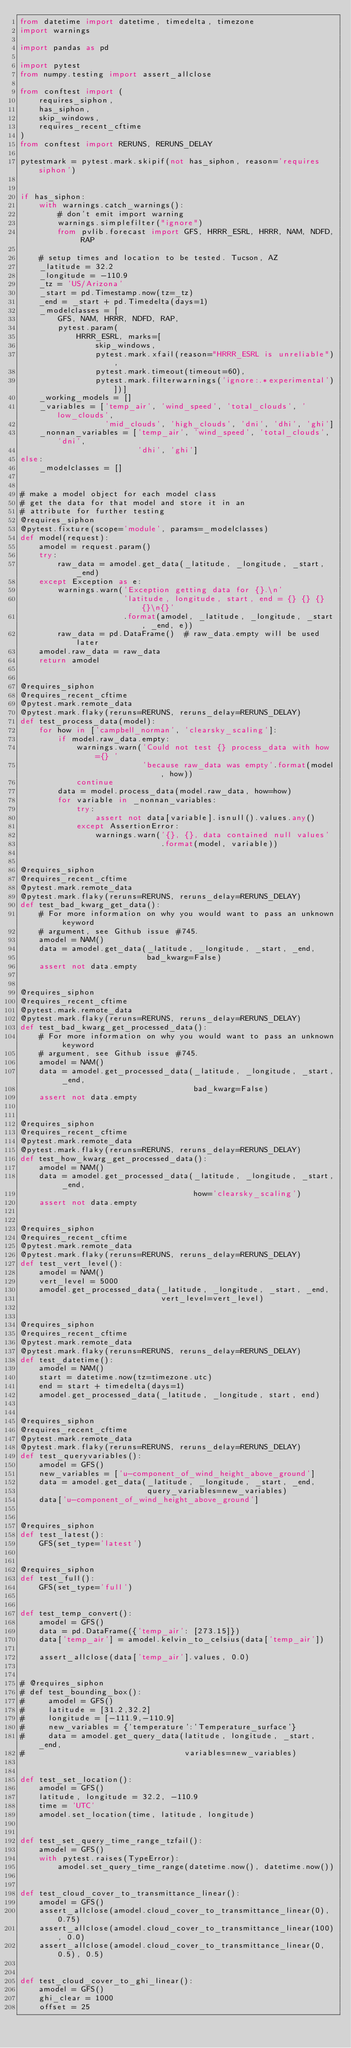Convert code to text. <code><loc_0><loc_0><loc_500><loc_500><_Python_>from datetime import datetime, timedelta, timezone
import warnings

import pandas as pd

import pytest
from numpy.testing import assert_allclose

from conftest import (
    requires_siphon,
    has_siphon,
    skip_windows,
    requires_recent_cftime
)
from conftest import RERUNS, RERUNS_DELAY

pytestmark = pytest.mark.skipif(not has_siphon, reason='requires siphon')


if has_siphon:
    with warnings.catch_warnings():
        # don't emit import warning
        warnings.simplefilter("ignore")
        from pvlib.forecast import GFS, HRRR_ESRL, HRRR, NAM, NDFD, RAP

    # setup times and location to be tested. Tucson, AZ
    _latitude = 32.2
    _longitude = -110.9
    _tz = 'US/Arizona'
    _start = pd.Timestamp.now(tz=_tz)
    _end = _start + pd.Timedelta(days=1)
    _modelclasses = [
        GFS, NAM, HRRR, NDFD, RAP,
        pytest.param(
            HRRR_ESRL, marks=[
                skip_windows,
                pytest.mark.xfail(reason="HRRR_ESRL is unreliable"),
                pytest.mark.timeout(timeout=60),
                pytest.mark.filterwarnings('ignore:.*experimental')])]
    _working_models = []
    _variables = ['temp_air', 'wind_speed', 'total_clouds', 'low_clouds',
                  'mid_clouds', 'high_clouds', 'dni', 'dhi', 'ghi']
    _nonnan_variables = ['temp_air', 'wind_speed', 'total_clouds', 'dni',
                         'dhi', 'ghi']
else:
    _modelclasses = []


# make a model object for each model class
# get the data for that model and store it in an
# attribute for further testing
@requires_siphon
@pytest.fixture(scope='module', params=_modelclasses)
def model(request):
    amodel = request.param()
    try:
        raw_data = amodel.get_data(_latitude, _longitude, _start, _end)
    except Exception as e:
        warnings.warn('Exception getting data for {}.\n'
                      'latitude, longitude, start, end = {} {} {} {}\n{}'
                      .format(amodel, _latitude, _longitude, _start, _end, e))
        raw_data = pd.DataFrame()  # raw_data.empty will be used later
    amodel.raw_data = raw_data
    return amodel


@requires_siphon
@requires_recent_cftime
@pytest.mark.remote_data
@pytest.mark.flaky(reruns=RERUNS, reruns_delay=RERUNS_DELAY)
def test_process_data(model):
    for how in ['campbell_norman', 'clearsky_scaling']:
        if model.raw_data.empty:
            warnings.warn('Could not test {} process_data with how={} '
                          'because raw_data was empty'.format(model, how))
            continue
        data = model.process_data(model.raw_data, how=how)
        for variable in _nonnan_variables:
            try:
                assert not data[variable].isnull().values.any()
            except AssertionError:
                warnings.warn('{}, {}, data contained null values'
                              .format(model, variable))


@requires_siphon
@requires_recent_cftime
@pytest.mark.remote_data
@pytest.mark.flaky(reruns=RERUNS, reruns_delay=RERUNS_DELAY)
def test_bad_kwarg_get_data():
    # For more information on why you would want to pass an unknown keyword
    # argument, see Github issue #745.
    amodel = NAM()
    data = amodel.get_data(_latitude, _longitude, _start, _end,
                           bad_kwarg=False)
    assert not data.empty


@requires_siphon
@requires_recent_cftime
@pytest.mark.remote_data
@pytest.mark.flaky(reruns=RERUNS, reruns_delay=RERUNS_DELAY)
def test_bad_kwarg_get_processed_data():
    # For more information on why you would want to pass an unknown keyword
    # argument, see Github issue #745.
    amodel = NAM()
    data = amodel.get_processed_data(_latitude, _longitude, _start, _end,
                                     bad_kwarg=False)
    assert not data.empty


@requires_siphon
@requires_recent_cftime
@pytest.mark.remote_data
@pytest.mark.flaky(reruns=RERUNS, reruns_delay=RERUNS_DELAY)
def test_how_kwarg_get_processed_data():
    amodel = NAM()
    data = amodel.get_processed_data(_latitude, _longitude, _start, _end,
                                     how='clearsky_scaling')
    assert not data.empty


@requires_siphon
@requires_recent_cftime
@pytest.mark.remote_data
@pytest.mark.flaky(reruns=RERUNS, reruns_delay=RERUNS_DELAY)
def test_vert_level():
    amodel = NAM()
    vert_level = 5000
    amodel.get_processed_data(_latitude, _longitude, _start, _end,
                              vert_level=vert_level)


@requires_siphon
@requires_recent_cftime
@pytest.mark.remote_data
@pytest.mark.flaky(reruns=RERUNS, reruns_delay=RERUNS_DELAY)
def test_datetime():
    amodel = NAM()
    start = datetime.now(tz=timezone.utc)
    end = start + timedelta(days=1)
    amodel.get_processed_data(_latitude, _longitude, start, end)


@requires_siphon
@requires_recent_cftime
@pytest.mark.remote_data
@pytest.mark.flaky(reruns=RERUNS, reruns_delay=RERUNS_DELAY)
def test_queryvariables():
    amodel = GFS()
    new_variables = ['u-component_of_wind_height_above_ground']
    data = amodel.get_data(_latitude, _longitude, _start, _end,
                           query_variables=new_variables)
    data['u-component_of_wind_height_above_ground']


@requires_siphon
def test_latest():
    GFS(set_type='latest')


@requires_siphon
def test_full():
    GFS(set_type='full')


def test_temp_convert():
    amodel = GFS()
    data = pd.DataFrame({'temp_air': [273.15]})
    data['temp_air'] = amodel.kelvin_to_celsius(data['temp_air'])

    assert_allclose(data['temp_air'].values, 0.0)


# @requires_siphon
# def test_bounding_box():
#     amodel = GFS()
#     latitude = [31.2,32.2]
#     longitude = [-111.9,-110.9]
#     new_variables = {'temperature':'Temperature_surface'}
#     data = amodel.get_query_data(latitude, longitude, _start, _end,
#                                  variables=new_variables)


def test_set_location():
    amodel = GFS()
    latitude, longitude = 32.2, -110.9
    time = 'UTC'
    amodel.set_location(time, latitude, longitude)


def test_set_query_time_range_tzfail():
    amodel = GFS()
    with pytest.raises(TypeError):
        amodel.set_query_time_range(datetime.now(), datetime.now())


def test_cloud_cover_to_transmittance_linear():
    amodel = GFS()
    assert_allclose(amodel.cloud_cover_to_transmittance_linear(0), 0.75)
    assert_allclose(amodel.cloud_cover_to_transmittance_linear(100), 0.0)
    assert_allclose(amodel.cloud_cover_to_transmittance_linear(0, 0.5), 0.5)


def test_cloud_cover_to_ghi_linear():
    amodel = GFS()
    ghi_clear = 1000
    offset = 25</code> 